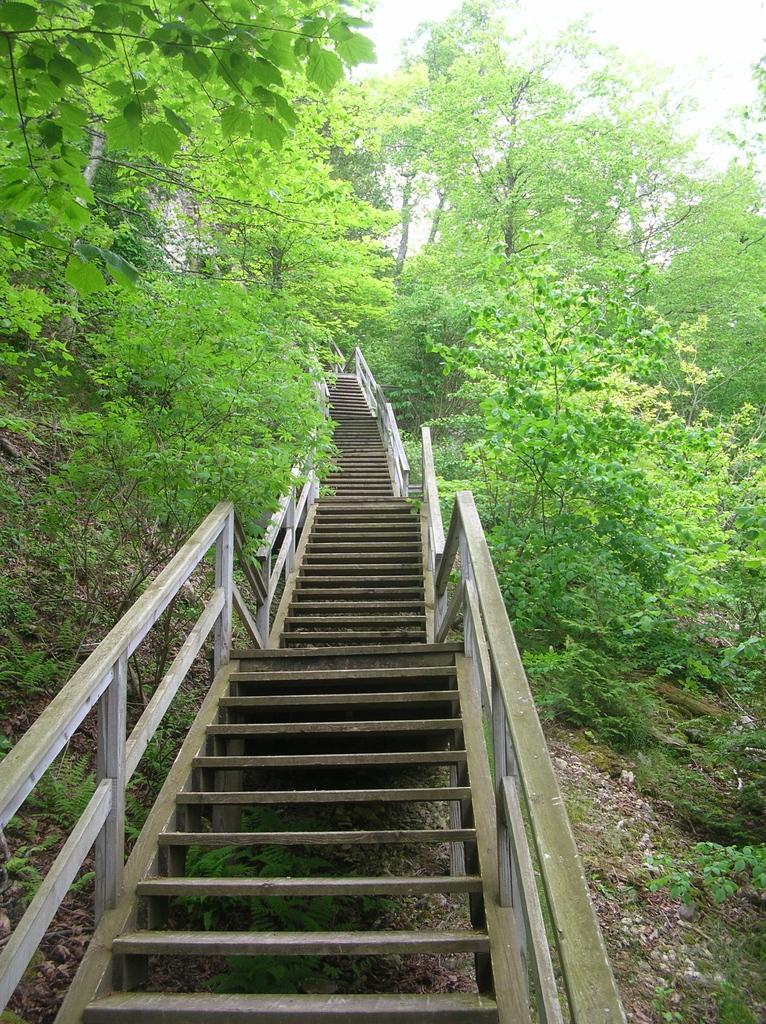Describe this image in one or two sentences. In the center of the image we can see the stairs. Image also consists of many trees. 